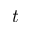Convert formula to latex. <formula><loc_0><loc_0><loc_500><loc_500>t</formula> 